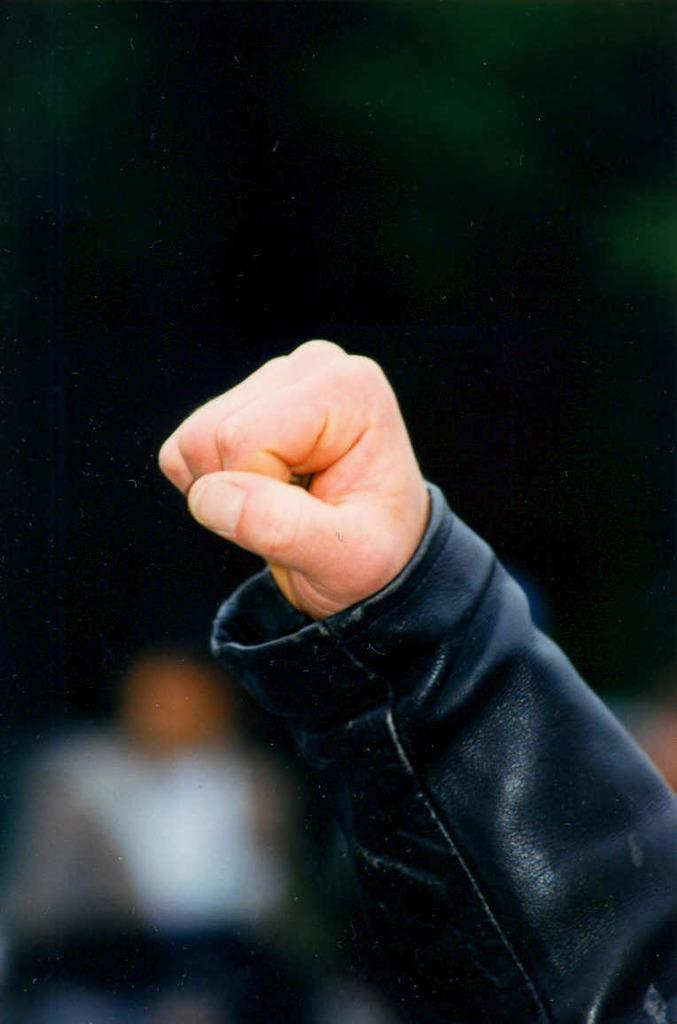What is the main subject of the image? The main subject of the image is a person's hand. Can you describe the hand in the image? The hand appears to be holding or touching something, but the specific object cannot be determined from the image. What part of the body is visible in the image? Only the hand is visible in the image. What type of hook is attached to the person's brain in the image? There is no hook or brain present in the image; it only features a person's hand. 